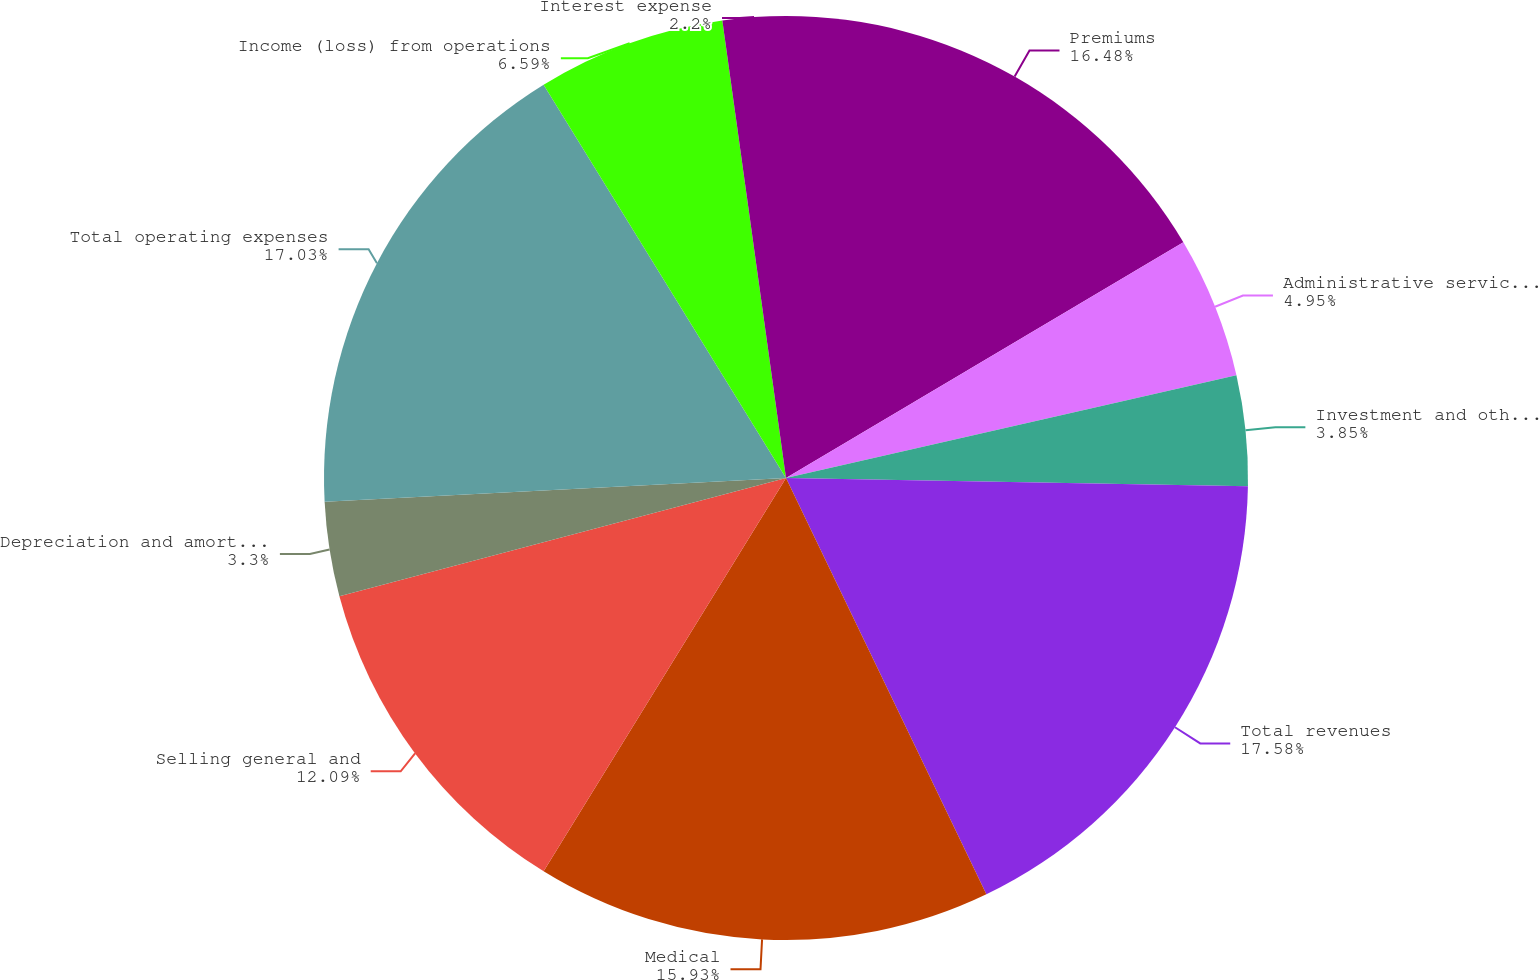<chart> <loc_0><loc_0><loc_500><loc_500><pie_chart><fcel>Premiums<fcel>Administrative services fees<fcel>Investment and other income<fcel>Total revenues<fcel>Medical<fcel>Selling general and<fcel>Depreciation and amortization<fcel>Total operating expenses<fcel>Income (loss) from operations<fcel>Interest expense<nl><fcel>16.48%<fcel>4.95%<fcel>3.85%<fcel>17.58%<fcel>15.93%<fcel>12.09%<fcel>3.3%<fcel>17.03%<fcel>6.59%<fcel>2.2%<nl></chart> 